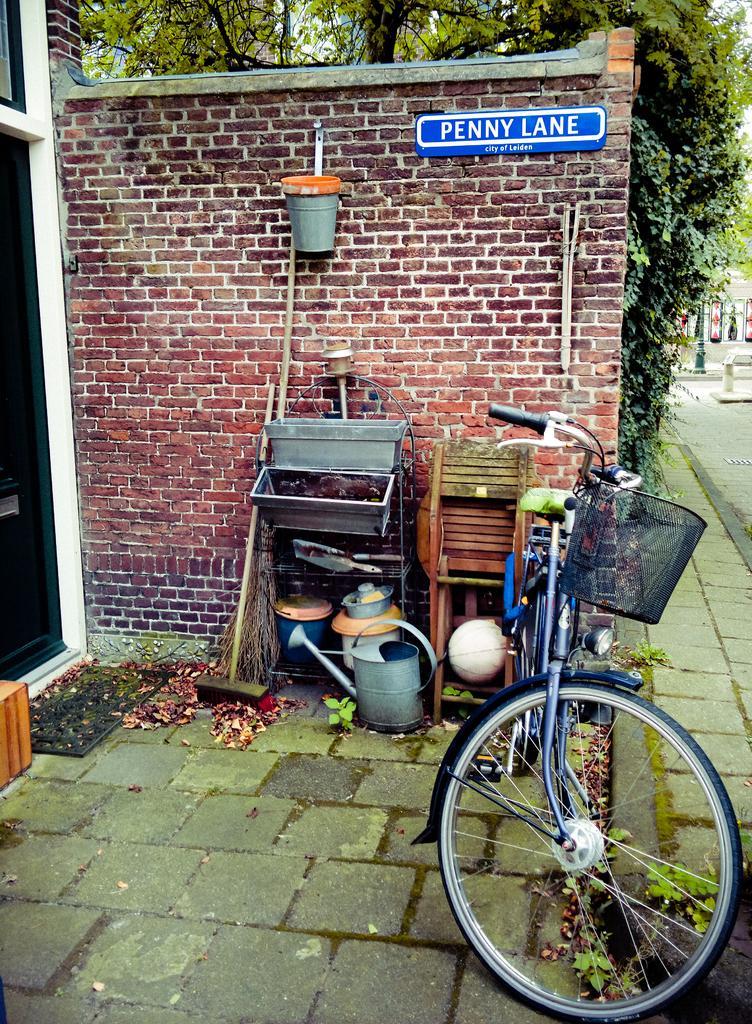How would you summarize this image in a sentence or two? In the middle of the image there is a bicycle. Behind the bicycle there are some sticks and stools and baskets. Behind them there is a wall. At the top of the image there are some trees. 